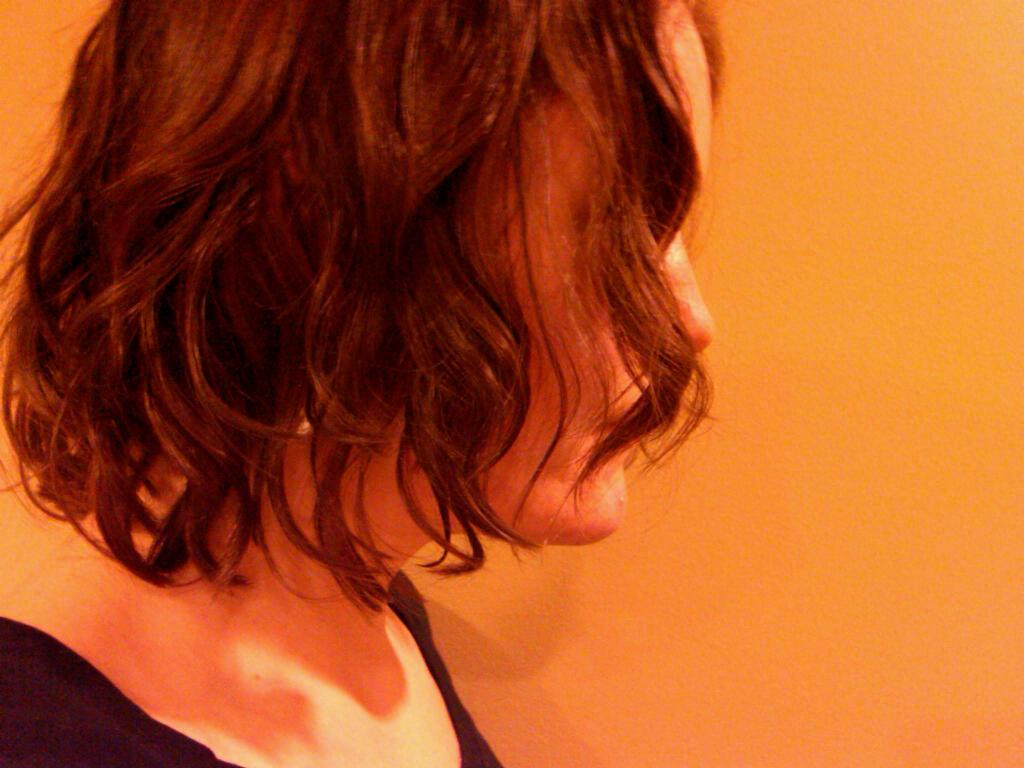Who or what is the main subject in the image? There is a person in the image. What is the person wearing? The person is wearing a black top. What can be seen in the background of the image? There is a wall in the background of the image. What type of meat is being cooked on the sand in the image? There is no sand or meat present in the image; it features a person wearing a black top with a wall in the background. 